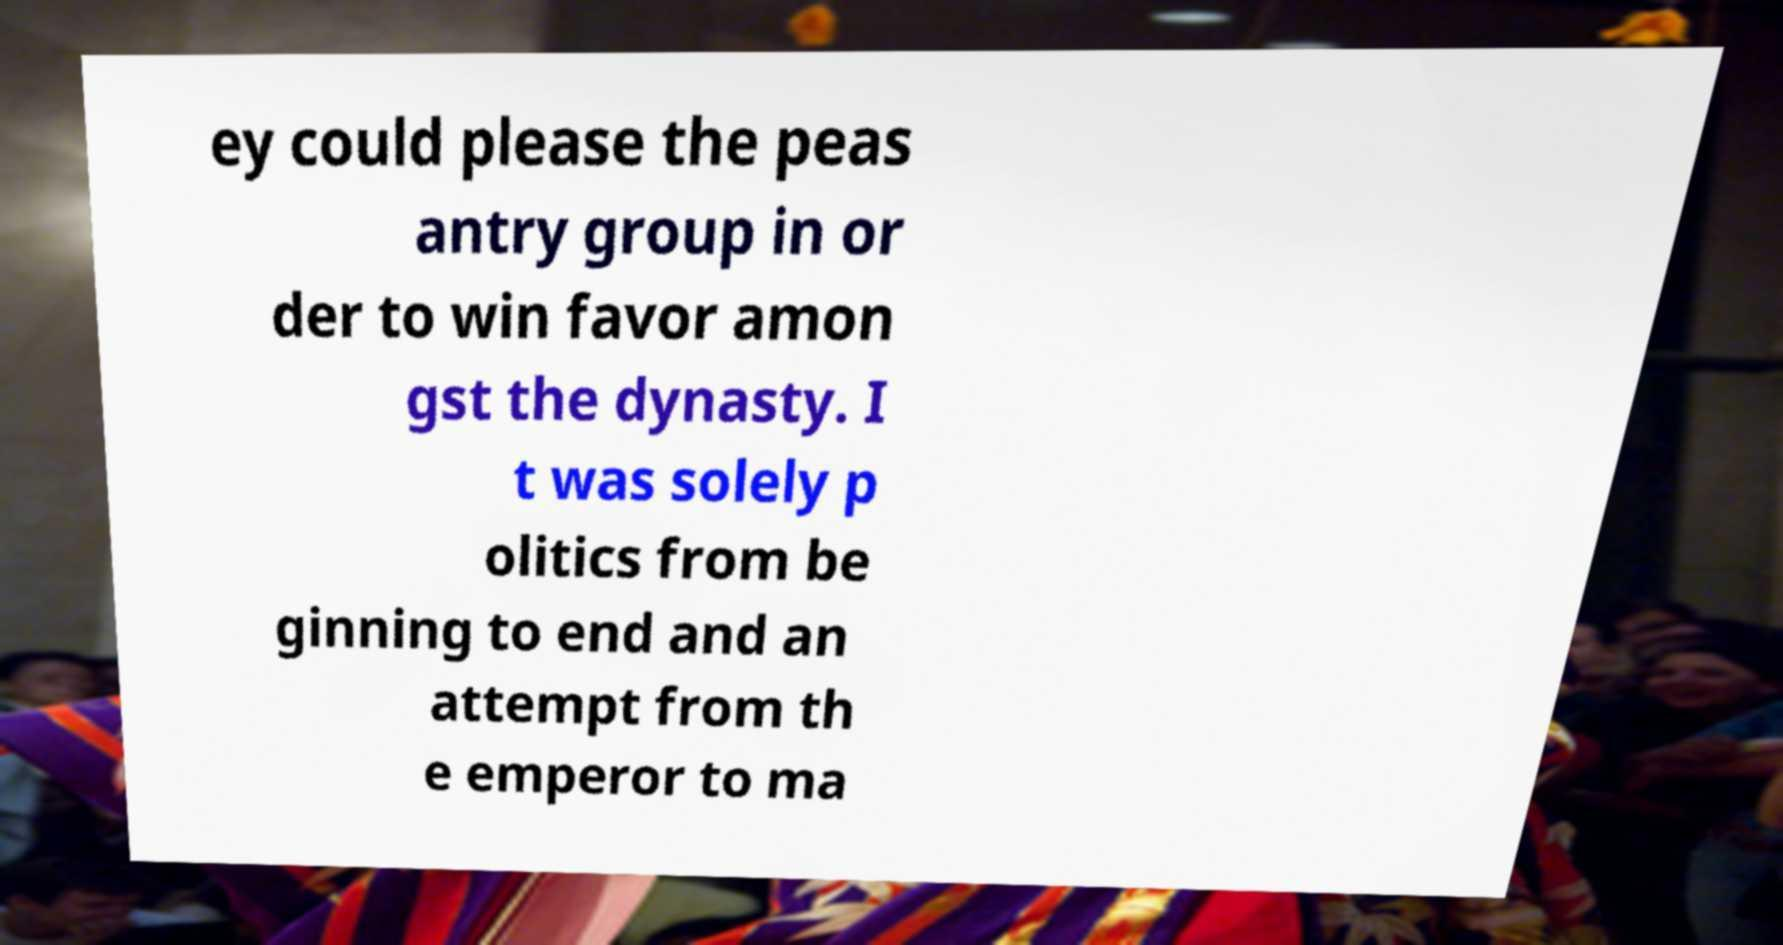There's text embedded in this image that I need extracted. Can you transcribe it verbatim? ey could please the peas antry group in or der to win favor amon gst the dynasty. I t was solely p olitics from be ginning to end and an attempt from th e emperor to ma 